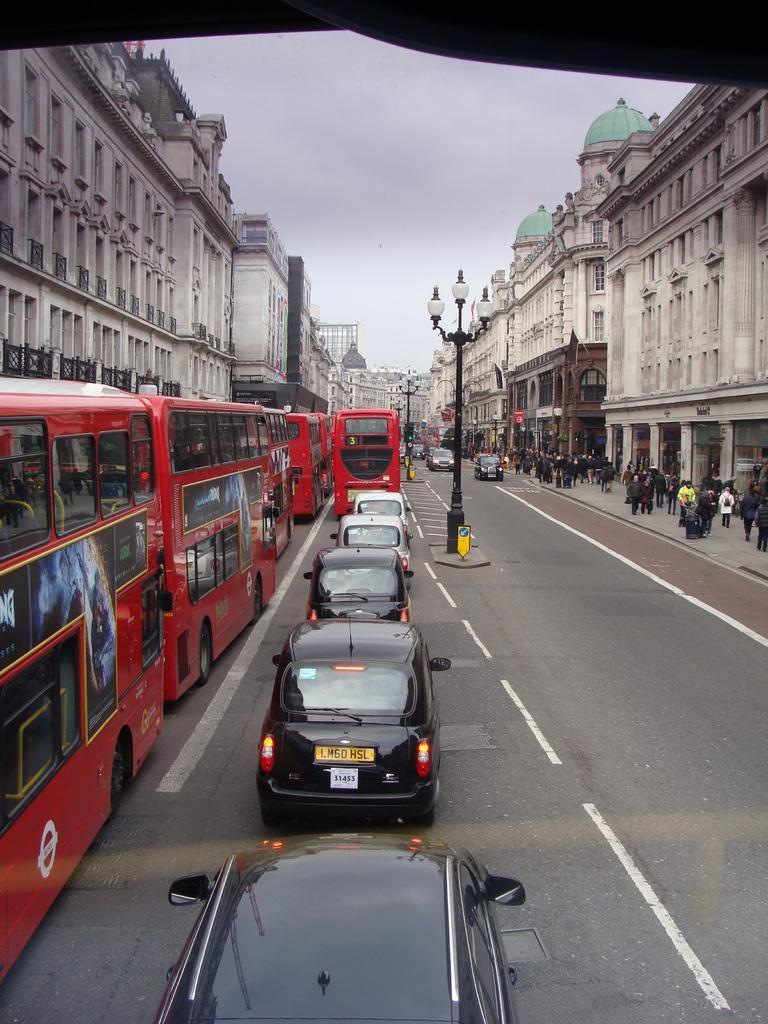In one or two sentences, can you explain what this image depicts? In this image we can see vehicles on the road. Also there are light poles. On the right side there are people. On both sides there are buildings. In the back there is sky. 